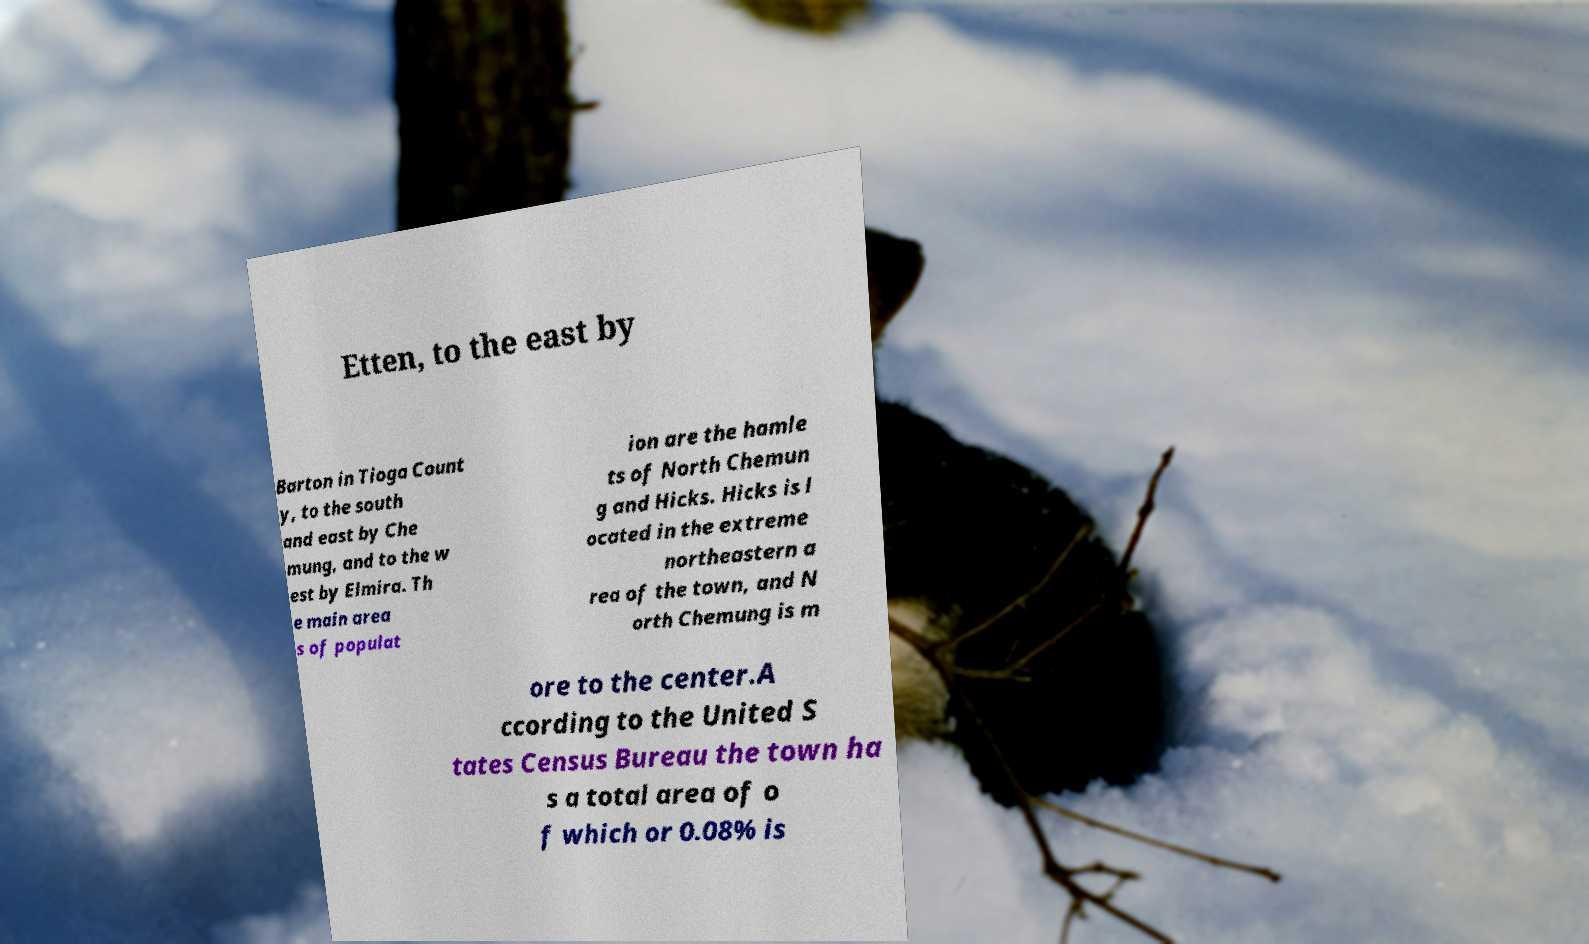There's text embedded in this image that I need extracted. Can you transcribe it verbatim? Etten, to the east by Barton in Tioga Count y, to the south and east by Che mung, and to the w est by Elmira. Th e main area s of populat ion are the hamle ts of North Chemun g and Hicks. Hicks is l ocated in the extreme northeastern a rea of the town, and N orth Chemung is m ore to the center.A ccording to the United S tates Census Bureau the town ha s a total area of o f which or 0.08% is 